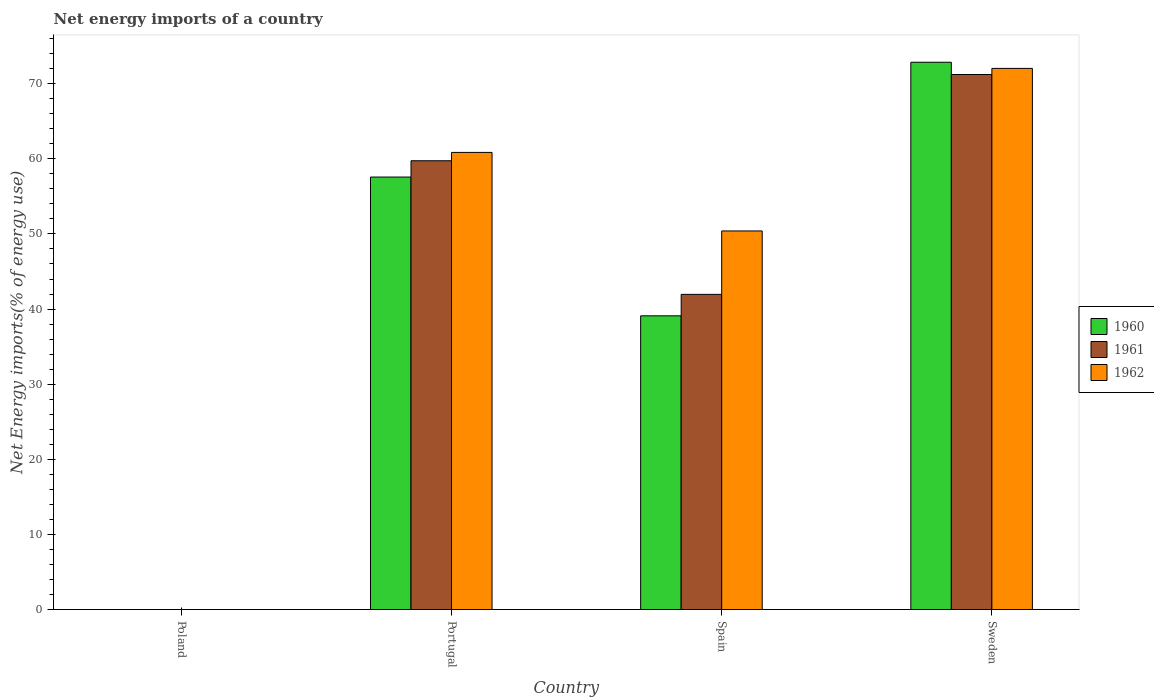Are the number of bars per tick equal to the number of legend labels?
Provide a short and direct response. No. Are the number of bars on each tick of the X-axis equal?
Make the answer very short. No. How many bars are there on the 1st tick from the right?
Offer a very short reply. 3. What is the label of the 1st group of bars from the left?
Provide a short and direct response. Poland. Across all countries, what is the maximum net energy imports in 1960?
Give a very brief answer. 72.86. Across all countries, what is the minimum net energy imports in 1962?
Keep it short and to the point. 0. What is the total net energy imports in 1961 in the graph?
Make the answer very short. 172.92. What is the difference between the net energy imports in 1960 in Spain and that in Sweden?
Provide a succinct answer. -33.76. What is the difference between the net energy imports in 1960 in Portugal and the net energy imports in 1961 in Spain?
Offer a terse response. 15.62. What is the average net energy imports in 1960 per country?
Make the answer very short. 42.38. What is the difference between the net energy imports of/in 1961 and net energy imports of/in 1962 in Portugal?
Your response must be concise. -1.11. In how many countries, is the net energy imports in 1960 greater than 44 %?
Ensure brevity in your answer.  2. What is the ratio of the net energy imports in 1960 in Portugal to that in Sweden?
Ensure brevity in your answer.  0.79. Is the net energy imports in 1961 in Spain less than that in Sweden?
Offer a terse response. Yes. Is the difference between the net energy imports in 1961 in Portugal and Spain greater than the difference between the net energy imports in 1962 in Portugal and Spain?
Give a very brief answer. Yes. What is the difference between the highest and the second highest net energy imports in 1962?
Offer a very short reply. 21.64. What is the difference between the highest and the lowest net energy imports in 1962?
Provide a short and direct response. 72.04. In how many countries, is the net energy imports in 1961 greater than the average net energy imports in 1961 taken over all countries?
Your answer should be very brief. 2. Is it the case that in every country, the sum of the net energy imports in 1961 and net energy imports in 1960 is greater than the net energy imports in 1962?
Offer a very short reply. No. Are all the bars in the graph horizontal?
Give a very brief answer. No. Are the values on the major ticks of Y-axis written in scientific E-notation?
Offer a very short reply. No. Does the graph contain grids?
Offer a very short reply. No. Where does the legend appear in the graph?
Offer a terse response. Center right. What is the title of the graph?
Your response must be concise. Net energy imports of a country. Does "2000" appear as one of the legend labels in the graph?
Offer a very short reply. No. What is the label or title of the X-axis?
Your answer should be compact. Country. What is the label or title of the Y-axis?
Provide a succinct answer. Net Energy imports(% of energy use). What is the Net Energy imports(% of energy use) in 1960 in Poland?
Your answer should be very brief. 0. What is the Net Energy imports(% of energy use) of 1962 in Poland?
Ensure brevity in your answer.  0. What is the Net Energy imports(% of energy use) in 1960 in Portugal?
Keep it short and to the point. 57.57. What is the Net Energy imports(% of energy use) of 1961 in Portugal?
Offer a terse response. 59.74. What is the Net Energy imports(% of energy use) in 1962 in Portugal?
Offer a terse response. 60.85. What is the Net Energy imports(% of energy use) of 1960 in Spain?
Your response must be concise. 39.1. What is the Net Energy imports(% of energy use) in 1961 in Spain?
Ensure brevity in your answer.  41.95. What is the Net Energy imports(% of energy use) of 1962 in Spain?
Provide a short and direct response. 50.4. What is the Net Energy imports(% of energy use) of 1960 in Sweden?
Provide a short and direct response. 72.86. What is the Net Energy imports(% of energy use) of 1961 in Sweden?
Offer a terse response. 71.22. What is the Net Energy imports(% of energy use) of 1962 in Sweden?
Provide a succinct answer. 72.04. Across all countries, what is the maximum Net Energy imports(% of energy use) in 1960?
Offer a very short reply. 72.86. Across all countries, what is the maximum Net Energy imports(% of energy use) in 1961?
Offer a terse response. 71.22. Across all countries, what is the maximum Net Energy imports(% of energy use) of 1962?
Provide a succinct answer. 72.04. Across all countries, what is the minimum Net Energy imports(% of energy use) in 1960?
Your response must be concise. 0. Across all countries, what is the minimum Net Energy imports(% of energy use) in 1962?
Give a very brief answer. 0. What is the total Net Energy imports(% of energy use) of 1960 in the graph?
Ensure brevity in your answer.  169.53. What is the total Net Energy imports(% of energy use) in 1961 in the graph?
Offer a very short reply. 172.92. What is the total Net Energy imports(% of energy use) of 1962 in the graph?
Make the answer very short. 183.29. What is the difference between the Net Energy imports(% of energy use) of 1960 in Portugal and that in Spain?
Keep it short and to the point. 18.47. What is the difference between the Net Energy imports(% of energy use) of 1961 in Portugal and that in Spain?
Keep it short and to the point. 17.79. What is the difference between the Net Energy imports(% of energy use) in 1962 in Portugal and that in Spain?
Provide a short and direct response. 10.46. What is the difference between the Net Energy imports(% of energy use) of 1960 in Portugal and that in Sweden?
Your response must be concise. -15.28. What is the difference between the Net Energy imports(% of energy use) in 1961 in Portugal and that in Sweden?
Your response must be concise. -11.48. What is the difference between the Net Energy imports(% of energy use) of 1962 in Portugal and that in Sweden?
Offer a very short reply. -11.18. What is the difference between the Net Energy imports(% of energy use) in 1960 in Spain and that in Sweden?
Offer a very short reply. -33.76. What is the difference between the Net Energy imports(% of energy use) in 1961 in Spain and that in Sweden?
Make the answer very short. -29.27. What is the difference between the Net Energy imports(% of energy use) of 1962 in Spain and that in Sweden?
Your answer should be very brief. -21.64. What is the difference between the Net Energy imports(% of energy use) in 1960 in Portugal and the Net Energy imports(% of energy use) in 1961 in Spain?
Provide a short and direct response. 15.62. What is the difference between the Net Energy imports(% of energy use) in 1960 in Portugal and the Net Energy imports(% of energy use) in 1962 in Spain?
Offer a very short reply. 7.18. What is the difference between the Net Energy imports(% of energy use) in 1961 in Portugal and the Net Energy imports(% of energy use) in 1962 in Spain?
Offer a terse response. 9.34. What is the difference between the Net Energy imports(% of energy use) in 1960 in Portugal and the Net Energy imports(% of energy use) in 1961 in Sweden?
Give a very brief answer. -13.65. What is the difference between the Net Energy imports(% of energy use) in 1960 in Portugal and the Net Energy imports(% of energy use) in 1962 in Sweden?
Your answer should be compact. -14.46. What is the difference between the Net Energy imports(% of energy use) of 1961 in Portugal and the Net Energy imports(% of energy use) of 1962 in Sweden?
Make the answer very short. -12.3. What is the difference between the Net Energy imports(% of energy use) of 1960 in Spain and the Net Energy imports(% of energy use) of 1961 in Sweden?
Your answer should be compact. -32.12. What is the difference between the Net Energy imports(% of energy use) in 1960 in Spain and the Net Energy imports(% of energy use) in 1962 in Sweden?
Make the answer very short. -32.94. What is the difference between the Net Energy imports(% of energy use) of 1961 in Spain and the Net Energy imports(% of energy use) of 1962 in Sweden?
Keep it short and to the point. -30.08. What is the average Net Energy imports(% of energy use) of 1960 per country?
Offer a terse response. 42.38. What is the average Net Energy imports(% of energy use) of 1961 per country?
Offer a very short reply. 43.23. What is the average Net Energy imports(% of energy use) of 1962 per country?
Your response must be concise. 45.82. What is the difference between the Net Energy imports(% of energy use) in 1960 and Net Energy imports(% of energy use) in 1961 in Portugal?
Offer a very short reply. -2.17. What is the difference between the Net Energy imports(% of energy use) in 1960 and Net Energy imports(% of energy use) in 1962 in Portugal?
Provide a succinct answer. -3.28. What is the difference between the Net Energy imports(% of energy use) of 1961 and Net Energy imports(% of energy use) of 1962 in Portugal?
Give a very brief answer. -1.11. What is the difference between the Net Energy imports(% of energy use) of 1960 and Net Energy imports(% of energy use) of 1961 in Spain?
Give a very brief answer. -2.85. What is the difference between the Net Energy imports(% of energy use) in 1960 and Net Energy imports(% of energy use) in 1962 in Spain?
Give a very brief answer. -11.3. What is the difference between the Net Energy imports(% of energy use) of 1961 and Net Energy imports(% of energy use) of 1962 in Spain?
Make the answer very short. -8.44. What is the difference between the Net Energy imports(% of energy use) in 1960 and Net Energy imports(% of energy use) in 1961 in Sweden?
Offer a very short reply. 1.63. What is the difference between the Net Energy imports(% of energy use) of 1960 and Net Energy imports(% of energy use) of 1962 in Sweden?
Provide a short and direct response. 0.82. What is the difference between the Net Energy imports(% of energy use) in 1961 and Net Energy imports(% of energy use) in 1962 in Sweden?
Ensure brevity in your answer.  -0.81. What is the ratio of the Net Energy imports(% of energy use) of 1960 in Portugal to that in Spain?
Your answer should be compact. 1.47. What is the ratio of the Net Energy imports(% of energy use) of 1961 in Portugal to that in Spain?
Provide a short and direct response. 1.42. What is the ratio of the Net Energy imports(% of energy use) in 1962 in Portugal to that in Spain?
Offer a very short reply. 1.21. What is the ratio of the Net Energy imports(% of energy use) in 1960 in Portugal to that in Sweden?
Keep it short and to the point. 0.79. What is the ratio of the Net Energy imports(% of energy use) of 1961 in Portugal to that in Sweden?
Keep it short and to the point. 0.84. What is the ratio of the Net Energy imports(% of energy use) in 1962 in Portugal to that in Sweden?
Provide a short and direct response. 0.84. What is the ratio of the Net Energy imports(% of energy use) of 1960 in Spain to that in Sweden?
Make the answer very short. 0.54. What is the ratio of the Net Energy imports(% of energy use) in 1961 in Spain to that in Sweden?
Provide a succinct answer. 0.59. What is the ratio of the Net Energy imports(% of energy use) of 1962 in Spain to that in Sweden?
Provide a short and direct response. 0.7. What is the difference between the highest and the second highest Net Energy imports(% of energy use) of 1960?
Make the answer very short. 15.28. What is the difference between the highest and the second highest Net Energy imports(% of energy use) of 1961?
Give a very brief answer. 11.48. What is the difference between the highest and the second highest Net Energy imports(% of energy use) in 1962?
Offer a terse response. 11.18. What is the difference between the highest and the lowest Net Energy imports(% of energy use) in 1960?
Your response must be concise. 72.86. What is the difference between the highest and the lowest Net Energy imports(% of energy use) in 1961?
Provide a succinct answer. 71.22. What is the difference between the highest and the lowest Net Energy imports(% of energy use) in 1962?
Offer a terse response. 72.04. 